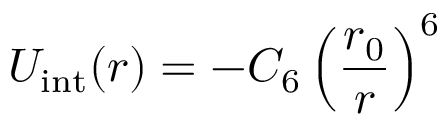<formula> <loc_0><loc_0><loc_500><loc_500>U _ { i n t } ( r ) = - C _ { 6 } \left ( \frac { r _ { 0 } } { r } \right ) ^ { 6 }</formula> 